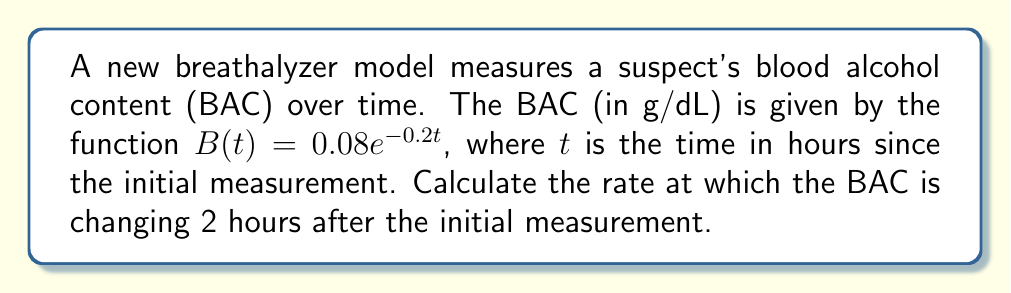Teach me how to tackle this problem. To solve this problem, we need to follow these steps:

1) The rate of change of BAC with respect to time is given by the derivative of $B(t)$.

2) Let's find the derivative of $B(t)$:
   
   $$\frac{d}{dt}B(t) = \frac{d}{dt}(0.08e^{-0.2t})$$
   
   Using the chain rule:
   
   $$\frac{d}{dt}B(t) = 0.08 \cdot (-0.2) \cdot e^{-0.2t}$$
   
   $$\frac{d}{dt}B(t) = -0.016e^{-0.2t}$$

3) This derivative represents the instantaneous rate of change of BAC at any time $t$.

4) To find the rate of change at $t = 2$ hours, we substitute $t = 2$ into our derivative:

   $$\left.\frac{d}{dt}B(t)\right|_{t=2} = -0.016e^{-0.2(2)}$$
   
   $$= -0.016e^{-0.4}$$
   
   $$\approx -0.0107 \text{ g/dL/hour}$$

5) The negative sign indicates that the BAC is decreasing over time.
Answer: $-0.0107 \text{ g/dL/hour}$ 